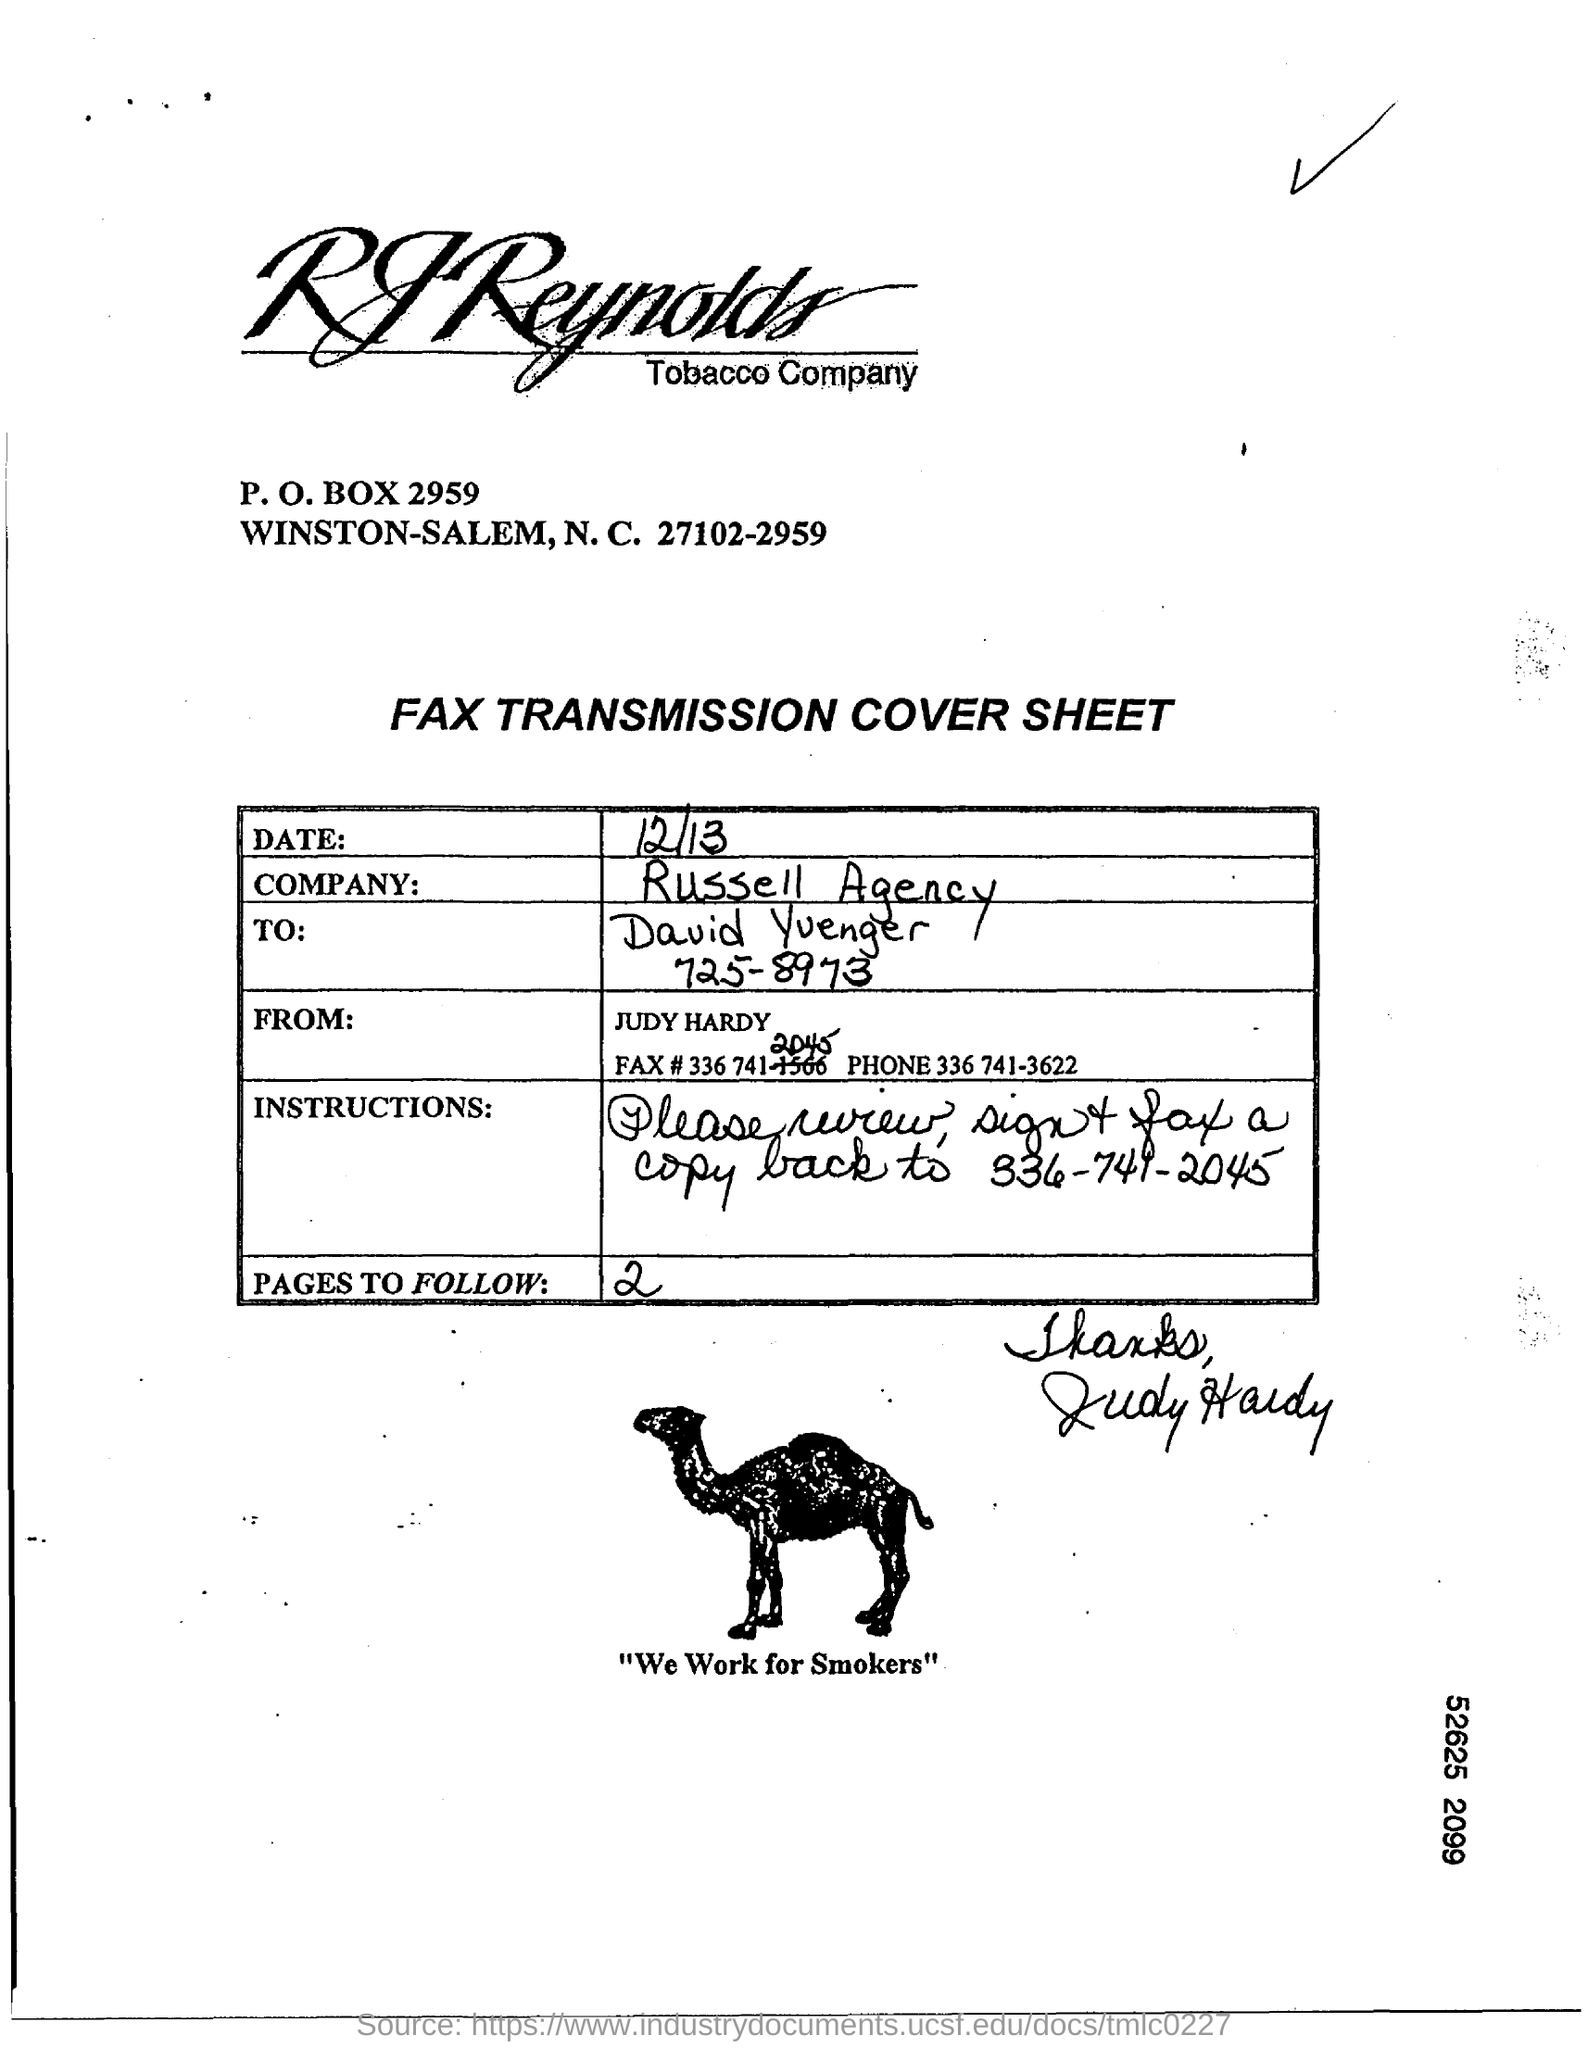What is the P.O. Box?
Give a very brief answer. 2959. What is the "Date"?
Your answer should be very brief. 12/13. What is the Phone no of Judy Hardy?
Make the answer very short. 336 741-3622. What is written below the picture of camel?
Provide a succinct answer. We Work for Smokers. 